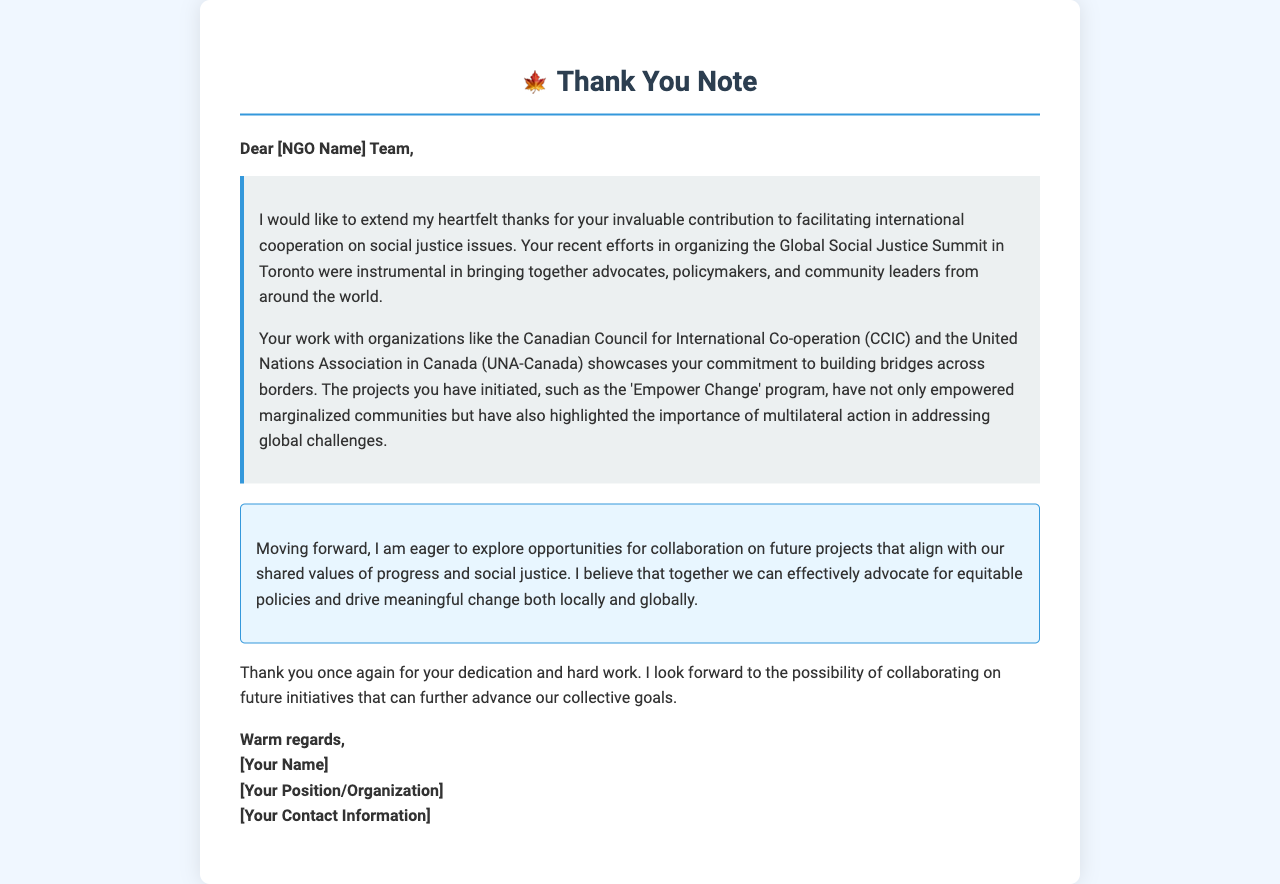What is the title of the document? The title is indicated in the header of the document, which is "Thank You Note".
Answer: Thank You Note Who is the recipient of the letter? The recipient is addressed in the greeting section of the document, which refers to them as "[NGO Name] Team".
Answer: [NGO Name] Team What event is mentioned in the letter? The letter refers to the "Global Social Justice Summit in Toronto".
Answer: Global Social Justice Summit in Toronto What program is highlighted in the document? The document mentions the "Empower Change" program as a specific initiative by the NGO.
Answer: Empower Change What is the main purpose of the letter? The purpose of the letter is to express gratitude and propose future collaboration opportunities with the NGO.
Answer: Express gratitude and propose future collaboration What sentiment does the author express towards the NGO's work? The author conveys a positive sentiment, emphasizing their "heartfelt thanks" for the NGO's contributions.
Answer: Heartfelt thanks What future action does the author want to explore? The author expresses eagerness to "explore opportunities for collaboration on future projects".
Answer: Explore opportunities for collaboration What is the signature closing? The signature closing includes "Warm regards," followed by space for the sender's details.
Answer: Warm regards What is the author's intention regarding future initiatives? The author intends to "collaborate on future initiatives that can further advance our collective goals."
Answer: Collaborate on future initiatives 